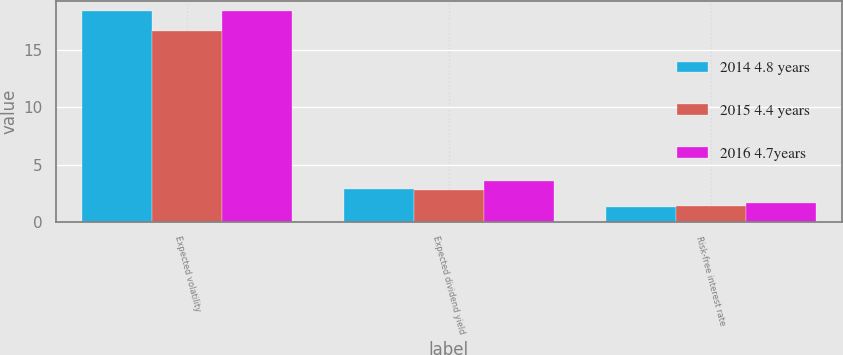<chart> <loc_0><loc_0><loc_500><loc_500><stacked_bar_chart><ecel><fcel>Expected volatility<fcel>Expected dividend yield<fcel>Risk-free interest rate<nl><fcel>2014 4.8 years<fcel>18.4<fcel>2.9<fcel>1.3<nl><fcel>2015 4.4 years<fcel>16.7<fcel>2.8<fcel>1.4<nl><fcel>2016 4.7years<fcel>18.4<fcel>3.6<fcel>1.6<nl></chart> 